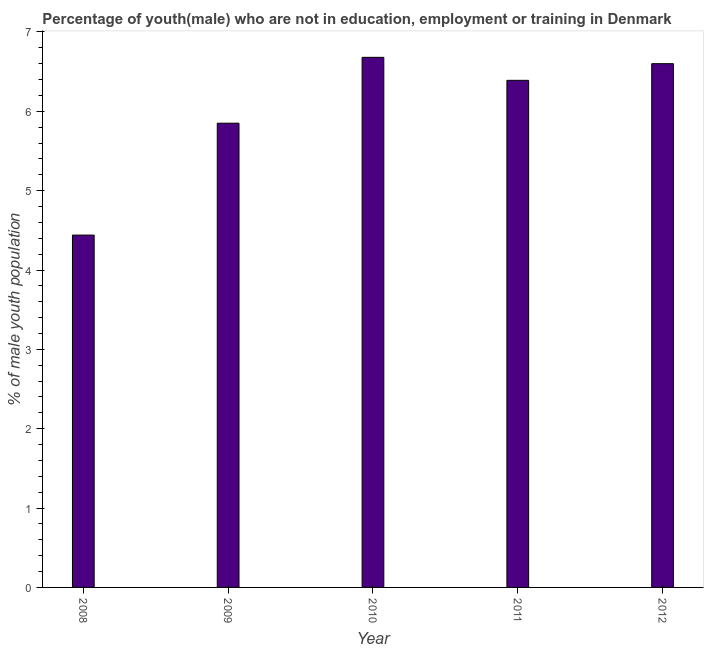Does the graph contain any zero values?
Ensure brevity in your answer.  No. Does the graph contain grids?
Make the answer very short. No. What is the title of the graph?
Ensure brevity in your answer.  Percentage of youth(male) who are not in education, employment or training in Denmark. What is the label or title of the X-axis?
Ensure brevity in your answer.  Year. What is the label or title of the Y-axis?
Offer a very short reply. % of male youth population. What is the unemployed male youth population in 2008?
Ensure brevity in your answer.  4.44. Across all years, what is the maximum unemployed male youth population?
Make the answer very short. 6.68. Across all years, what is the minimum unemployed male youth population?
Offer a terse response. 4.44. What is the sum of the unemployed male youth population?
Offer a terse response. 29.96. What is the difference between the unemployed male youth population in 2008 and 2011?
Ensure brevity in your answer.  -1.95. What is the average unemployed male youth population per year?
Your answer should be very brief. 5.99. What is the median unemployed male youth population?
Your answer should be very brief. 6.39. Do a majority of the years between 2008 and 2012 (inclusive) have unemployed male youth population greater than 3 %?
Provide a short and direct response. Yes. Is the difference between the unemployed male youth population in 2011 and 2012 greater than the difference between any two years?
Your answer should be very brief. No. Is the sum of the unemployed male youth population in 2009 and 2011 greater than the maximum unemployed male youth population across all years?
Your answer should be compact. Yes. What is the difference between the highest and the lowest unemployed male youth population?
Ensure brevity in your answer.  2.24. How many bars are there?
Give a very brief answer. 5. Are all the bars in the graph horizontal?
Offer a very short reply. No. How many years are there in the graph?
Make the answer very short. 5. Are the values on the major ticks of Y-axis written in scientific E-notation?
Your answer should be very brief. No. What is the % of male youth population of 2008?
Provide a succinct answer. 4.44. What is the % of male youth population of 2009?
Offer a very short reply. 5.85. What is the % of male youth population of 2010?
Offer a terse response. 6.68. What is the % of male youth population in 2011?
Give a very brief answer. 6.39. What is the % of male youth population in 2012?
Ensure brevity in your answer.  6.6. What is the difference between the % of male youth population in 2008 and 2009?
Offer a terse response. -1.41. What is the difference between the % of male youth population in 2008 and 2010?
Make the answer very short. -2.24. What is the difference between the % of male youth population in 2008 and 2011?
Your response must be concise. -1.95. What is the difference between the % of male youth population in 2008 and 2012?
Provide a succinct answer. -2.16. What is the difference between the % of male youth population in 2009 and 2010?
Your answer should be very brief. -0.83. What is the difference between the % of male youth population in 2009 and 2011?
Give a very brief answer. -0.54. What is the difference between the % of male youth population in 2009 and 2012?
Your answer should be compact. -0.75. What is the difference between the % of male youth population in 2010 and 2011?
Make the answer very short. 0.29. What is the difference between the % of male youth population in 2010 and 2012?
Your answer should be compact. 0.08. What is the difference between the % of male youth population in 2011 and 2012?
Your response must be concise. -0.21. What is the ratio of the % of male youth population in 2008 to that in 2009?
Your answer should be very brief. 0.76. What is the ratio of the % of male youth population in 2008 to that in 2010?
Ensure brevity in your answer.  0.67. What is the ratio of the % of male youth population in 2008 to that in 2011?
Your response must be concise. 0.69. What is the ratio of the % of male youth population in 2008 to that in 2012?
Your response must be concise. 0.67. What is the ratio of the % of male youth population in 2009 to that in 2010?
Provide a short and direct response. 0.88. What is the ratio of the % of male youth population in 2009 to that in 2011?
Offer a terse response. 0.92. What is the ratio of the % of male youth population in 2009 to that in 2012?
Your answer should be very brief. 0.89. What is the ratio of the % of male youth population in 2010 to that in 2011?
Offer a very short reply. 1.04. What is the ratio of the % of male youth population in 2010 to that in 2012?
Your response must be concise. 1.01. What is the ratio of the % of male youth population in 2011 to that in 2012?
Give a very brief answer. 0.97. 